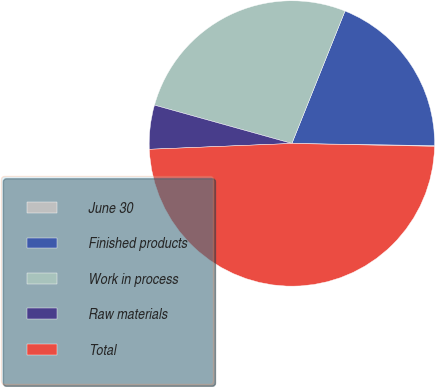Convert chart to OTSL. <chart><loc_0><loc_0><loc_500><loc_500><pie_chart><fcel>June 30<fcel>Finished products<fcel>Work in process<fcel>Raw materials<fcel>Total<nl><fcel>0.08%<fcel>19.17%<fcel>26.74%<fcel>4.98%<fcel>49.03%<nl></chart> 